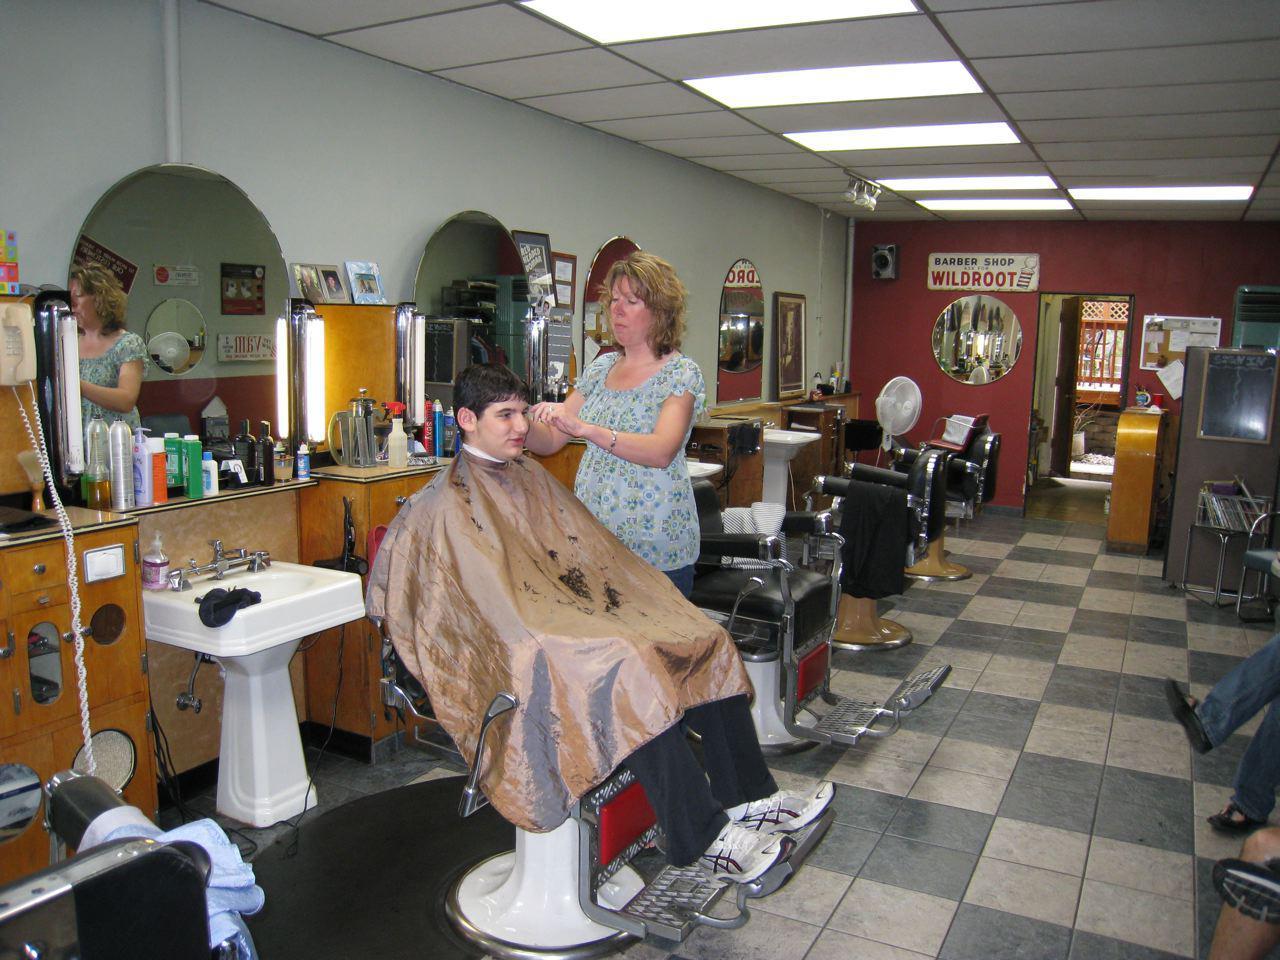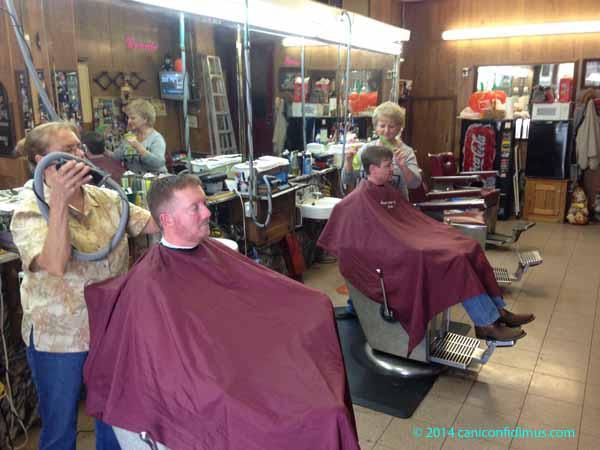The first image is the image on the left, the second image is the image on the right. For the images displayed, is the sentence "An image shows salon customers wearing purple protective capes." factually correct? Answer yes or no. Yes. The first image is the image on the left, the second image is the image on the right. For the images shown, is this caption "At least one of the images has someone getting their hair cut with a purple apron over their laps." true? Answer yes or no. Yes. 